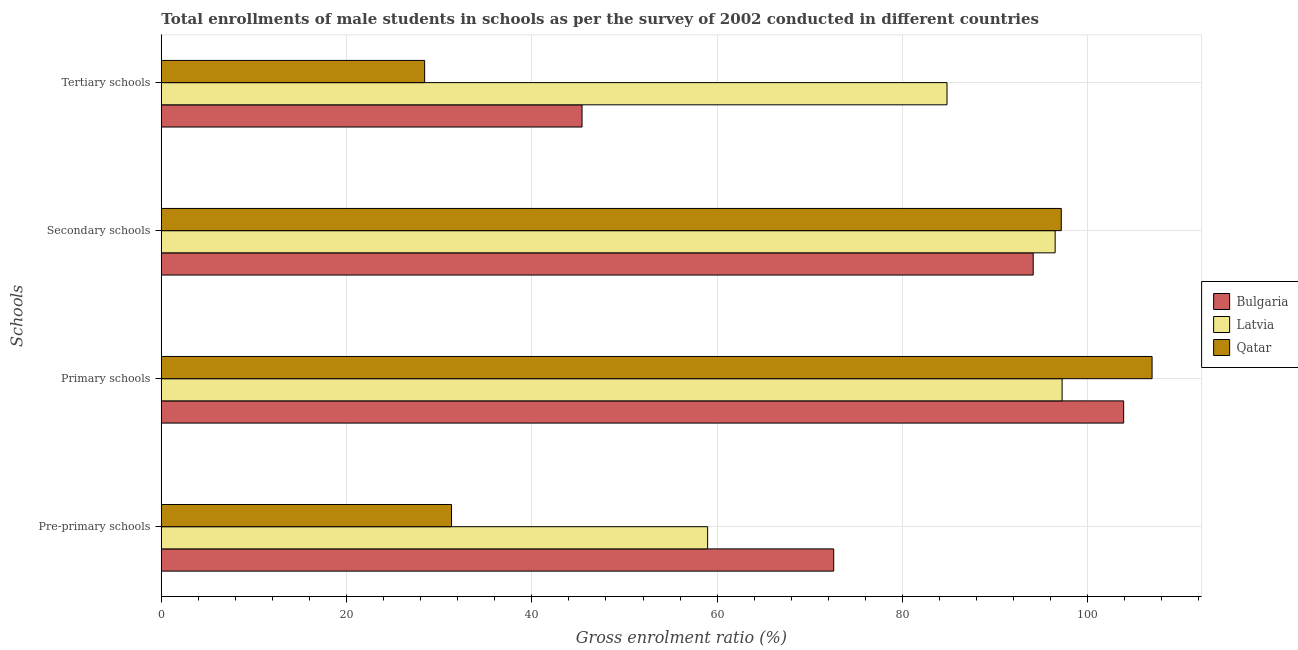How many different coloured bars are there?
Give a very brief answer. 3. Are the number of bars per tick equal to the number of legend labels?
Your answer should be very brief. Yes. How many bars are there on the 3rd tick from the bottom?
Your answer should be compact. 3. What is the label of the 4th group of bars from the top?
Ensure brevity in your answer.  Pre-primary schools. What is the gross enrolment ratio(male) in pre-primary schools in Qatar?
Offer a very short reply. 31.33. Across all countries, what is the maximum gross enrolment ratio(male) in pre-primary schools?
Keep it short and to the point. 72.58. Across all countries, what is the minimum gross enrolment ratio(male) in secondary schools?
Provide a succinct answer. 94.11. In which country was the gross enrolment ratio(male) in primary schools maximum?
Your answer should be compact. Qatar. What is the total gross enrolment ratio(male) in secondary schools in the graph?
Offer a terse response. 287.74. What is the difference between the gross enrolment ratio(male) in pre-primary schools in Bulgaria and that in Qatar?
Your answer should be compact. 41.26. What is the difference between the gross enrolment ratio(male) in pre-primary schools in Qatar and the gross enrolment ratio(male) in secondary schools in Latvia?
Your response must be concise. -65.16. What is the average gross enrolment ratio(male) in tertiary schools per country?
Your response must be concise. 52.88. What is the difference between the gross enrolment ratio(male) in pre-primary schools and gross enrolment ratio(male) in primary schools in Qatar?
Your response must be concise. -75.62. In how many countries, is the gross enrolment ratio(male) in secondary schools greater than 72 %?
Make the answer very short. 3. What is the ratio of the gross enrolment ratio(male) in primary schools in Latvia to that in Bulgaria?
Provide a succinct answer. 0.94. Is the difference between the gross enrolment ratio(male) in pre-primary schools in Bulgaria and Latvia greater than the difference between the gross enrolment ratio(male) in primary schools in Bulgaria and Latvia?
Your response must be concise. Yes. What is the difference between the highest and the second highest gross enrolment ratio(male) in pre-primary schools?
Ensure brevity in your answer.  13.61. What is the difference between the highest and the lowest gross enrolment ratio(male) in secondary schools?
Your answer should be very brief. 3.03. In how many countries, is the gross enrolment ratio(male) in tertiary schools greater than the average gross enrolment ratio(male) in tertiary schools taken over all countries?
Your response must be concise. 1. Is the sum of the gross enrolment ratio(male) in tertiary schools in Latvia and Bulgaria greater than the maximum gross enrolment ratio(male) in primary schools across all countries?
Give a very brief answer. Yes. What does the 3rd bar from the top in Pre-primary schools represents?
Your answer should be very brief. Bulgaria. Is it the case that in every country, the sum of the gross enrolment ratio(male) in pre-primary schools and gross enrolment ratio(male) in primary schools is greater than the gross enrolment ratio(male) in secondary schools?
Give a very brief answer. Yes. Are all the bars in the graph horizontal?
Ensure brevity in your answer.  Yes. What is the difference between two consecutive major ticks on the X-axis?
Your response must be concise. 20. Does the graph contain any zero values?
Your response must be concise. No. Where does the legend appear in the graph?
Keep it short and to the point. Center right. How many legend labels are there?
Make the answer very short. 3. What is the title of the graph?
Make the answer very short. Total enrollments of male students in schools as per the survey of 2002 conducted in different countries. Does "Sint Maarten (Dutch part)" appear as one of the legend labels in the graph?
Give a very brief answer. No. What is the label or title of the X-axis?
Provide a short and direct response. Gross enrolment ratio (%). What is the label or title of the Y-axis?
Your answer should be compact. Schools. What is the Gross enrolment ratio (%) of Bulgaria in Pre-primary schools?
Give a very brief answer. 72.58. What is the Gross enrolment ratio (%) in Latvia in Pre-primary schools?
Provide a short and direct response. 58.97. What is the Gross enrolment ratio (%) in Qatar in Pre-primary schools?
Offer a terse response. 31.33. What is the Gross enrolment ratio (%) of Bulgaria in Primary schools?
Your answer should be compact. 103.88. What is the Gross enrolment ratio (%) in Latvia in Primary schools?
Ensure brevity in your answer.  97.24. What is the Gross enrolment ratio (%) in Qatar in Primary schools?
Offer a very short reply. 106.95. What is the Gross enrolment ratio (%) of Bulgaria in Secondary schools?
Offer a terse response. 94.11. What is the Gross enrolment ratio (%) in Latvia in Secondary schools?
Provide a succinct answer. 96.48. What is the Gross enrolment ratio (%) of Qatar in Secondary schools?
Ensure brevity in your answer.  97.15. What is the Gross enrolment ratio (%) in Bulgaria in Tertiary schools?
Give a very brief answer. 45.42. What is the Gross enrolment ratio (%) in Latvia in Tertiary schools?
Your answer should be compact. 84.81. What is the Gross enrolment ratio (%) in Qatar in Tertiary schools?
Keep it short and to the point. 28.42. Across all Schools, what is the maximum Gross enrolment ratio (%) in Bulgaria?
Make the answer very short. 103.88. Across all Schools, what is the maximum Gross enrolment ratio (%) of Latvia?
Make the answer very short. 97.24. Across all Schools, what is the maximum Gross enrolment ratio (%) of Qatar?
Give a very brief answer. 106.95. Across all Schools, what is the minimum Gross enrolment ratio (%) in Bulgaria?
Provide a succinct answer. 45.42. Across all Schools, what is the minimum Gross enrolment ratio (%) in Latvia?
Offer a very short reply. 58.97. Across all Schools, what is the minimum Gross enrolment ratio (%) in Qatar?
Your answer should be compact. 28.42. What is the total Gross enrolment ratio (%) in Bulgaria in the graph?
Ensure brevity in your answer.  315.99. What is the total Gross enrolment ratio (%) in Latvia in the graph?
Offer a terse response. 337.5. What is the total Gross enrolment ratio (%) in Qatar in the graph?
Offer a very short reply. 263.84. What is the difference between the Gross enrolment ratio (%) in Bulgaria in Pre-primary schools and that in Primary schools?
Provide a succinct answer. -31.3. What is the difference between the Gross enrolment ratio (%) of Latvia in Pre-primary schools and that in Primary schools?
Your answer should be compact. -38.27. What is the difference between the Gross enrolment ratio (%) of Qatar in Pre-primary schools and that in Primary schools?
Ensure brevity in your answer.  -75.62. What is the difference between the Gross enrolment ratio (%) of Bulgaria in Pre-primary schools and that in Secondary schools?
Offer a very short reply. -21.53. What is the difference between the Gross enrolment ratio (%) in Latvia in Pre-primary schools and that in Secondary schools?
Offer a terse response. -37.51. What is the difference between the Gross enrolment ratio (%) in Qatar in Pre-primary schools and that in Secondary schools?
Ensure brevity in your answer.  -65.82. What is the difference between the Gross enrolment ratio (%) of Bulgaria in Pre-primary schools and that in Tertiary schools?
Your answer should be very brief. 27.17. What is the difference between the Gross enrolment ratio (%) in Latvia in Pre-primary schools and that in Tertiary schools?
Offer a very short reply. -25.84. What is the difference between the Gross enrolment ratio (%) of Qatar in Pre-primary schools and that in Tertiary schools?
Ensure brevity in your answer.  2.9. What is the difference between the Gross enrolment ratio (%) of Bulgaria in Primary schools and that in Secondary schools?
Ensure brevity in your answer.  9.77. What is the difference between the Gross enrolment ratio (%) in Latvia in Primary schools and that in Secondary schools?
Offer a terse response. 0.75. What is the difference between the Gross enrolment ratio (%) in Qatar in Primary schools and that in Secondary schools?
Ensure brevity in your answer.  9.8. What is the difference between the Gross enrolment ratio (%) in Bulgaria in Primary schools and that in Tertiary schools?
Provide a short and direct response. 58.46. What is the difference between the Gross enrolment ratio (%) in Latvia in Primary schools and that in Tertiary schools?
Ensure brevity in your answer.  12.42. What is the difference between the Gross enrolment ratio (%) of Qatar in Primary schools and that in Tertiary schools?
Offer a terse response. 78.52. What is the difference between the Gross enrolment ratio (%) of Bulgaria in Secondary schools and that in Tertiary schools?
Your answer should be compact. 48.7. What is the difference between the Gross enrolment ratio (%) of Latvia in Secondary schools and that in Tertiary schools?
Offer a terse response. 11.67. What is the difference between the Gross enrolment ratio (%) of Qatar in Secondary schools and that in Tertiary schools?
Your response must be concise. 68.72. What is the difference between the Gross enrolment ratio (%) in Bulgaria in Pre-primary schools and the Gross enrolment ratio (%) in Latvia in Primary schools?
Your response must be concise. -24.65. What is the difference between the Gross enrolment ratio (%) in Bulgaria in Pre-primary schools and the Gross enrolment ratio (%) in Qatar in Primary schools?
Your answer should be very brief. -34.37. What is the difference between the Gross enrolment ratio (%) in Latvia in Pre-primary schools and the Gross enrolment ratio (%) in Qatar in Primary schools?
Give a very brief answer. -47.98. What is the difference between the Gross enrolment ratio (%) in Bulgaria in Pre-primary schools and the Gross enrolment ratio (%) in Latvia in Secondary schools?
Ensure brevity in your answer.  -23.9. What is the difference between the Gross enrolment ratio (%) in Bulgaria in Pre-primary schools and the Gross enrolment ratio (%) in Qatar in Secondary schools?
Make the answer very short. -24.56. What is the difference between the Gross enrolment ratio (%) of Latvia in Pre-primary schools and the Gross enrolment ratio (%) of Qatar in Secondary schools?
Offer a very short reply. -38.18. What is the difference between the Gross enrolment ratio (%) in Bulgaria in Pre-primary schools and the Gross enrolment ratio (%) in Latvia in Tertiary schools?
Ensure brevity in your answer.  -12.23. What is the difference between the Gross enrolment ratio (%) in Bulgaria in Pre-primary schools and the Gross enrolment ratio (%) in Qatar in Tertiary schools?
Provide a short and direct response. 44.16. What is the difference between the Gross enrolment ratio (%) in Latvia in Pre-primary schools and the Gross enrolment ratio (%) in Qatar in Tertiary schools?
Make the answer very short. 30.55. What is the difference between the Gross enrolment ratio (%) in Bulgaria in Primary schools and the Gross enrolment ratio (%) in Latvia in Secondary schools?
Provide a succinct answer. 7.4. What is the difference between the Gross enrolment ratio (%) in Bulgaria in Primary schools and the Gross enrolment ratio (%) in Qatar in Secondary schools?
Offer a very short reply. 6.73. What is the difference between the Gross enrolment ratio (%) in Latvia in Primary schools and the Gross enrolment ratio (%) in Qatar in Secondary schools?
Your response must be concise. 0.09. What is the difference between the Gross enrolment ratio (%) in Bulgaria in Primary schools and the Gross enrolment ratio (%) in Latvia in Tertiary schools?
Keep it short and to the point. 19.07. What is the difference between the Gross enrolment ratio (%) of Bulgaria in Primary schools and the Gross enrolment ratio (%) of Qatar in Tertiary schools?
Provide a succinct answer. 75.46. What is the difference between the Gross enrolment ratio (%) of Latvia in Primary schools and the Gross enrolment ratio (%) of Qatar in Tertiary schools?
Offer a terse response. 68.81. What is the difference between the Gross enrolment ratio (%) in Bulgaria in Secondary schools and the Gross enrolment ratio (%) in Latvia in Tertiary schools?
Keep it short and to the point. 9.3. What is the difference between the Gross enrolment ratio (%) of Bulgaria in Secondary schools and the Gross enrolment ratio (%) of Qatar in Tertiary schools?
Your answer should be compact. 65.69. What is the difference between the Gross enrolment ratio (%) of Latvia in Secondary schools and the Gross enrolment ratio (%) of Qatar in Tertiary schools?
Your answer should be very brief. 68.06. What is the average Gross enrolment ratio (%) in Bulgaria per Schools?
Provide a short and direct response. 79. What is the average Gross enrolment ratio (%) of Latvia per Schools?
Your response must be concise. 84.38. What is the average Gross enrolment ratio (%) in Qatar per Schools?
Your response must be concise. 65.96. What is the difference between the Gross enrolment ratio (%) of Bulgaria and Gross enrolment ratio (%) of Latvia in Pre-primary schools?
Offer a very short reply. 13.61. What is the difference between the Gross enrolment ratio (%) in Bulgaria and Gross enrolment ratio (%) in Qatar in Pre-primary schools?
Your response must be concise. 41.26. What is the difference between the Gross enrolment ratio (%) of Latvia and Gross enrolment ratio (%) of Qatar in Pre-primary schools?
Your response must be concise. 27.65. What is the difference between the Gross enrolment ratio (%) in Bulgaria and Gross enrolment ratio (%) in Latvia in Primary schools?
Your response must be concise. 6.64. What is the difference between the Gross enrolment ratio (%) of Bulgaria and Gross enrolment ratio (%) of Qatar in Primary schools?
Offer a terse response. -3.07. What is the difference between the Gross enrolment ratio (%) in Latvia and Gross enrolment ratio (%) in Qatar in Primary schools?
Provide a short and direct response. -9.71. What is the difference between the Gross enrolment ratio (%) of Bulgaria and Gross enrolment ratio (%) of Latvia in Secondary schools?
Ensure brevity in your answer.  -2.37. What is the difference between the Gross enrolment ratio (%) of Bulgaria and Gross enrolment ratio (%) of Qatar in Secondary schools?
Your response must be concise. -3.03. What is the difference between the Gross enrolment ratio (%) of Latvia and Gross enrolment ratio (%) of Qatar in Secondary schools?
Offer a terse response. -0.66. What is the difference between the Gross enrolment ratio (%) of Bulgaria and Gross enrolment ratio (%) of Latvia in Tertiary schools?
Ensure brevity in your answer.  -39.4. What is the difference between the Gross enrolment ratio (%) of Bulgaria and Gross enrolment ratio (%) of Qatar in Tertiary schools?
Your answer should be very brief. 16.99. What is the difference between the Gross enrolment ratio (%) in Latvia and Gross enrolment ratio (%) in Qatar in Tertiary schools?
Provide a short and direct response. 56.39. What is the ratio of the Gross enrolment ratio (%) of Bulgaria in Pre-primary schools to that in Primary schools?
Your answer should be very brief. 0.7. What is the ratio of the Gross enrolment ratio (%) in Latvia in Pre-primary schools to that in Primary schools?
Keep it short and to the point. 0.61. What is the ratio of the Gross enrolment ratio (%) in Qatar in Pre-primary schools to that in Primary schools?
Your response must be concise. 0.29. What is the ratio of the Gross enrolment ratio (%) in Bulgaria in Pre-primary schools to that in Secondary schools?
Provide a short and direct response. 0.77. What is the ratio of the Gross enrolment ratio (%) of Latvia in Pre-primary schools to that in Secondary schools?
Provide a short and direct response. 0.61. What is the ratio of the Gross enrolment ratio (%) of Qatar in Pre-primary schools to that in Secondary schools?
Give a very brief answer. 0.32. What is the ratio of the Gross enrolment ratio (%) in Bulgaria in Pre-primary schools to that in Tertiary schools?
Give a very brief answer. 1.6. What is the ratio of the Gross enrolment ratio (%) of Latvia in Pre-primary schools to that in Tertiary schools?
Provide a succinct answer. 0.7. What is the ratio of the Gross enrolment ratio (%) in Qatar in Pre-primary schools to that in Tertiary schools?
Ensure brevity in your answer.  1.1. What is the ratio of the Gross enrolment ratio (%) of Bulgaria in Primary schools to that in Secondary schools?
Your response must be concise. 1.1. What is the ratio of the Gross enrolment ratio (%) of Qatar in Primary schools to that in Secondary schools?
Offer a terse response. 1.1. What is the ratio of the Gross enrolment ratio (%) of Bulgaria in Primary schools to that in Tertiary schools?
Offer a terse response. 2.29. What is the ratio of the Gross enrolment ratio (%) of Latvia in Primary schools to that in Tertiary schools?
Your answer should be very brief. 1.15. What is the ratio of the Gross enrolment ratio (%) of Qatar in Primary schools to that in Tertiary schools?
Your answer should be compact. 3.76. What is the ratio of the Gross enrolment ratio (%) of Bulgaria in Secondary schools to that in Tertiary schools?
Your answer should be compact. 2.07. What is the ratio of the Gross enrolment ratio (%) in Latvia in Secondary schools to that in Tertiary schools?
Your response must be concise. 1.14. What is the ratio of the Gross enrolment ratio (%) of Qatar in Secondary schools to that in Tertiary schools?
Ensure brevity in your answer.  3.42. What is the difference between the highest and the second highest Gross enrolment ratio (%) in Bulgaria?
Give a very brief answer. 9.77. What is the difference between the highest and the second highest Gross enrolment ratio (%) in Latvia?
Offer a terse response. 0.75. What is the difference between the highest and the second highest Gross enrolment ratio (%) of Qatar?
Ensure brevity in your answer.  9.8. What is the difference between the highest and the lowest Gross enrolment ratio (%) in Bulgaria?
Make the answer very short. 58.46. What is the difference between the highest and the lowest Gross enrolment ratio (%) of Latvia?
Make the answer very short. 38.27. What is the difference between the highest and the lowest Gross enrolment ratio (%) in Qatar?
Ensure brevity in your answer.  78.52. 